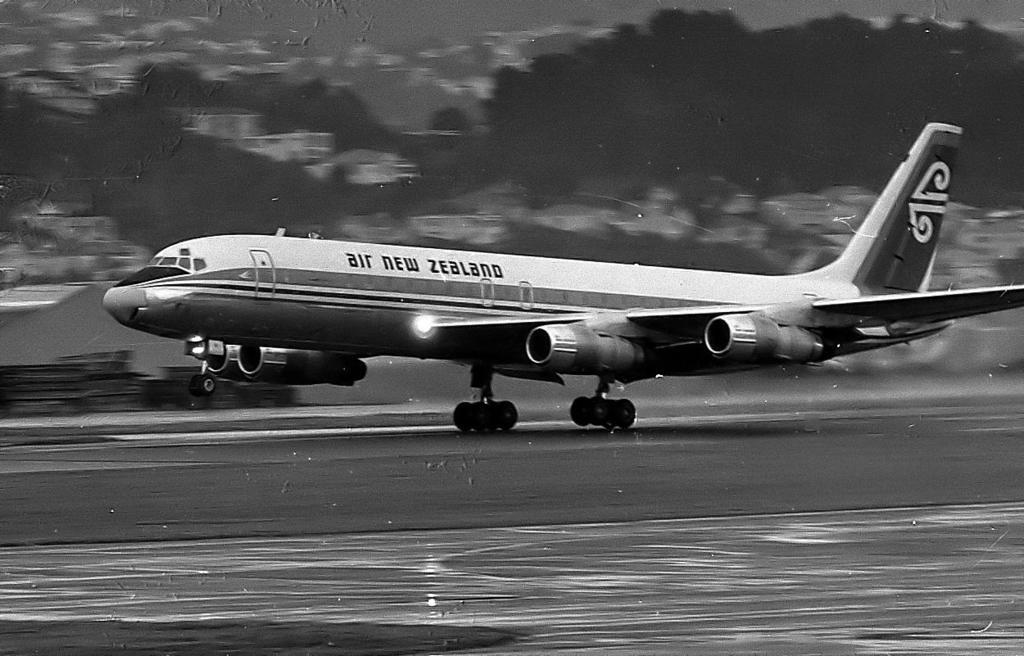<image>
Create a compact narrative representing the image presented. A black and white image of an Air New Zealand plane. 